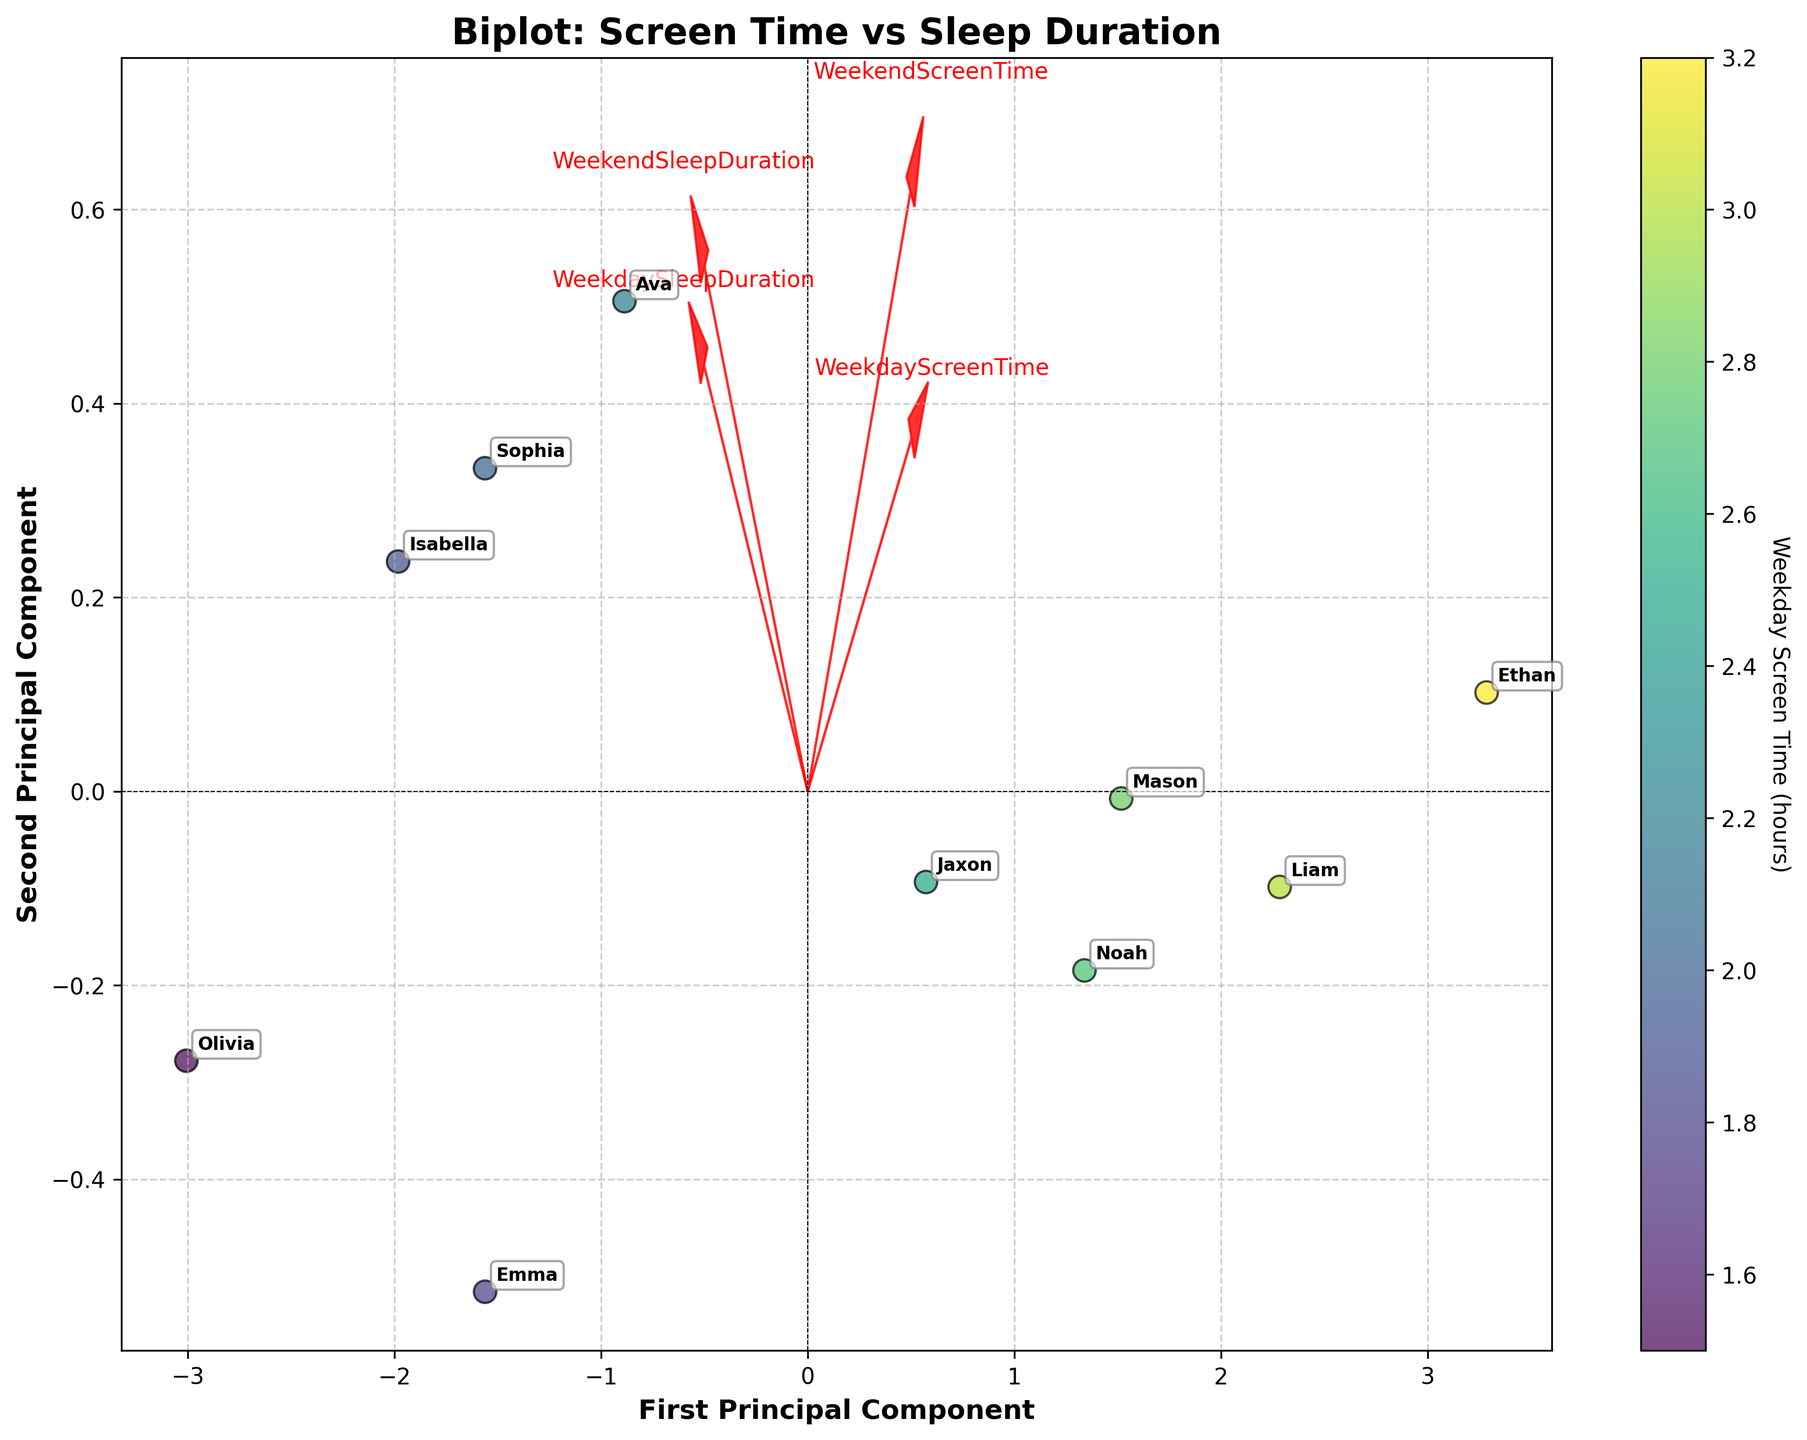What is the title of the figure? The title can be found at the top of the figure. It helps in understanding the context of the data depicted.
Answer: Biplot: Screen Time vs Sleep Duration How many arrows are there, and what do they represent? There are four arrows, each representing a different feature from the dataset: Weekday Screen Time, Weekend Screen Time, Weekday Sleep Duration, and Weekend Sleep Duration.
Answer: Four arrows Which principal component explains more variance? The principal component that has the larger spread along its axis explains more variance. By comparing the horizontal and vertical spreads, we can determine that the first principal component (x-axis) explains more variance.
Answer: First Principal Component Which two features seem most positively correlated based on the direction of the arrows? Features that have arrows pointing in similar directions are positively correlated. By examining the direction of the arrows in the biplot, we observe that Weekend Sleep Duration and Weekday Sleep Duration have arrows pointing in similar directions.
Answer: Weekday Sleep Duration and Weekend Sleep Duration Is Jaxon’s data point grouped relatively closely to Emma's or Ethan's in the figure? To compare data points, we look at their positions in the biplot. Jaxon's data point is closer to Emma's as compared to Ethan's, judging by the proximity of their labels.
Answer: Emma's Which child has the highest weekday screen time, and how can you tell? The color of the data points represents the Weekday Screen Time. The child with the darkest data point has the highest Weekday Screen Time.
Answer: Ethan What is the general trend of Weekend Screen Time across the dataset? By examining the direction of the Weekend Screen Time arrow and its correlation with the other features, we can deduce that higher Weekend Screen Time is generally associated with higher Weekday Screen Time and lower Weekday Sleep Duration but positively correlated with Weekend Sleep Duration.
Answer: Higher Weekend Screen Time tends to associate with higher Weekday Screen Time and various sleep durations Which principal component axis (first or second) is more influenced by screen time variables? By examining the lengths and directions of the arrows representing Weekday and Weekend Screen Time, we note which principal component (x or y) is more aligned with these arrows. The first principal component (x-axis) is more influenced by screen time variables.
Answer: First Principal Component Do children generally sleep more on weekends compared to weekdays? By comparing the direction and lengths of the arrows for Weekday Sleep Duration and Weekend Sleep Duration and observing their relative positions, we can conclude if there is generally an increase in sleep duration on weekends. The arrow for Weekend Sleep Duration suggests a positive correlation along its axis, indicating more sleep on weekends.
Answer: Yes Which child has the largest discrepancy between weekday and weekend screen time, based on the figure? The distance between data points and the color indication might help in judging the discrepancy visually. Ethan’s placement and darker color might indicate a higher discrepancy.
Answer: Ethan 